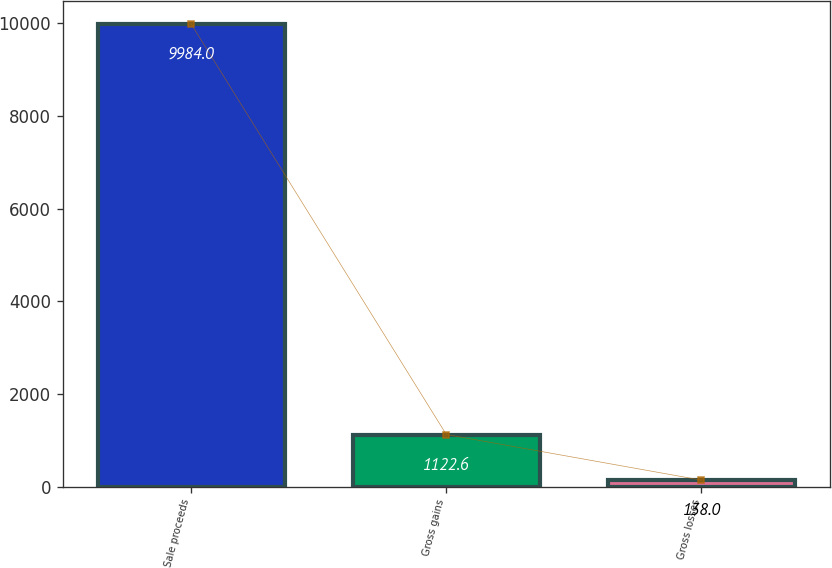<chart> <loc_0><loc_0><loc_500><loc_500><bar_chart><fcel>Sale proceeds<fcel>Gross gains<fcel>Gross losses<nl><fcel>9984<fcel>1122.6<fcel>138<nl></chart> 